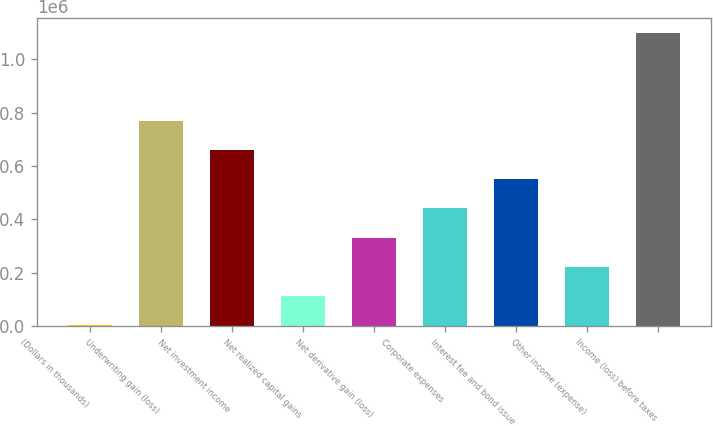Convert chart. <chart><loc_0><loc_0><loc_500><loc_500><bar_chart><fcel>(Dollars in thousands)<fcel>Underwriting gain (loss)<fcel>Net investment income<fcel>Net realized capital gains<fcel>Net derivative gain (loss)<fcel>Corporate expenses<fcel>Interest fee and bond issue<fcel>Other income (expense)<fcel>Income (loss) before taxes<nl><fcel>2016<fcel>770496<fcel>660713<fcel>111799<fcel>331364<fcel>441147<fcel>550930<fcel>221582<fcel>1.09984e+06<nl></chart> 